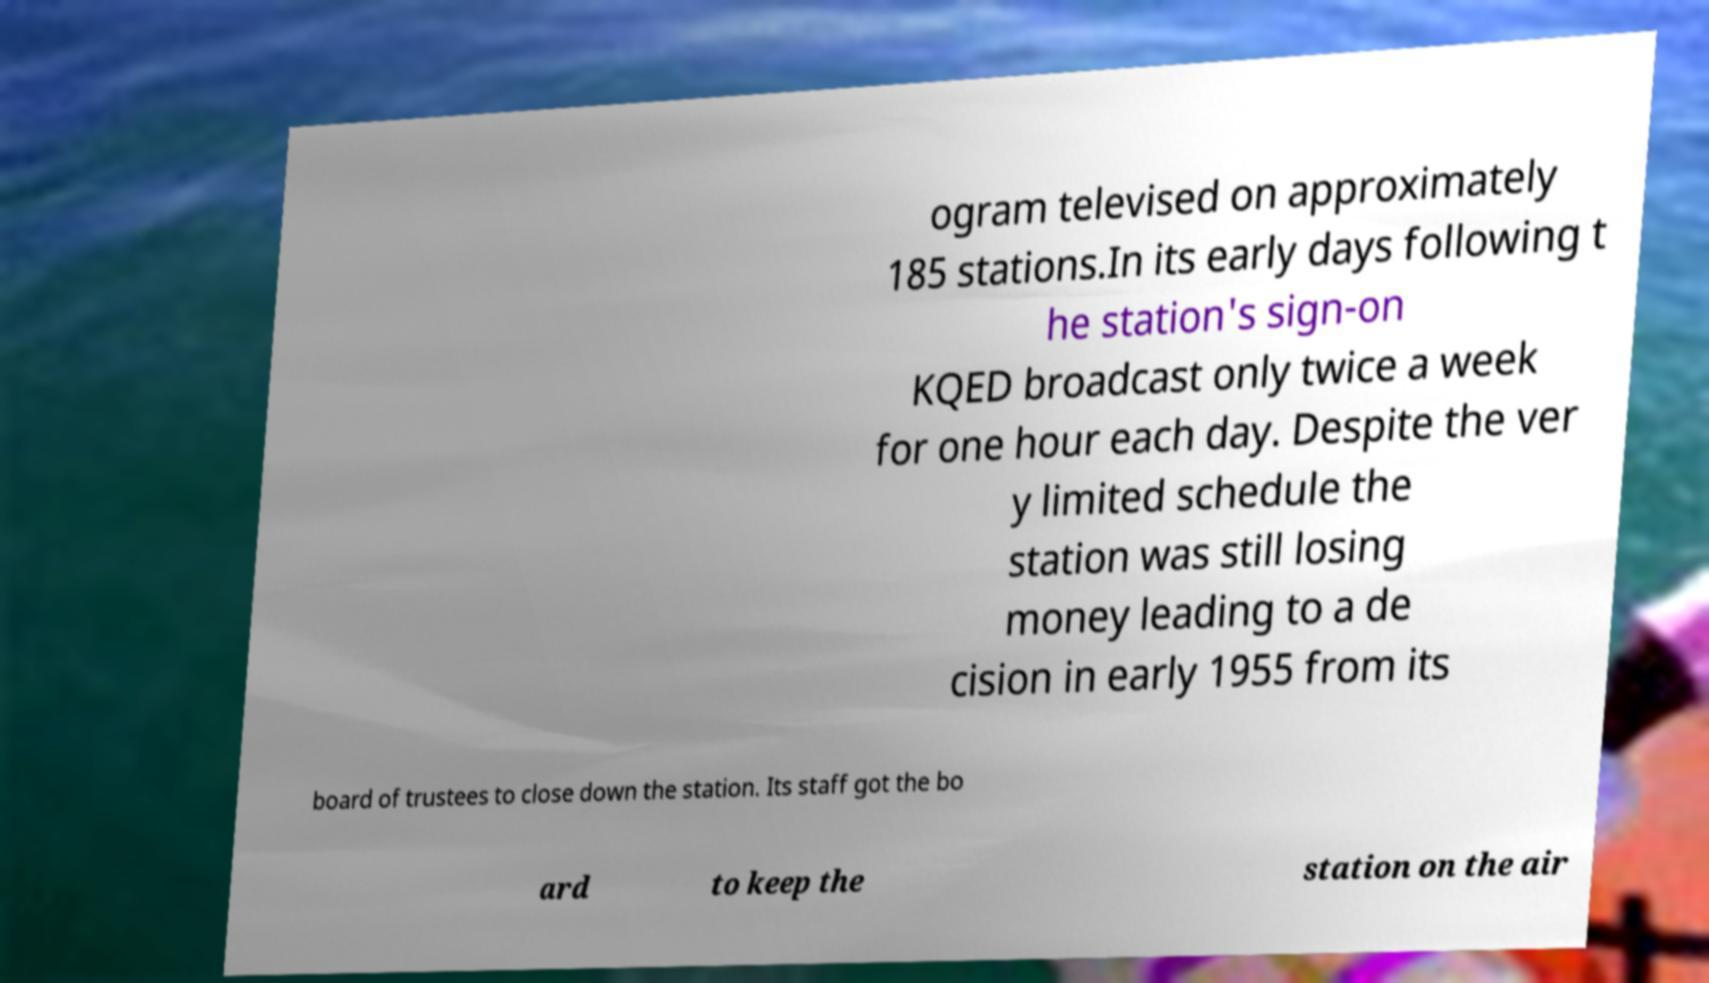I need the written content from this picture converted into text. Can you do that? ogram televised on approximately 185 stations.In its early days following t he station's sign-on KQED broadcast only twice a week for one hour each day. Despite the ver y limited schedule the station was still losing money leading to a de cision in early 1955 from its board of trustees to close down the station. Its staff got the bo ard to keep the station on the air 